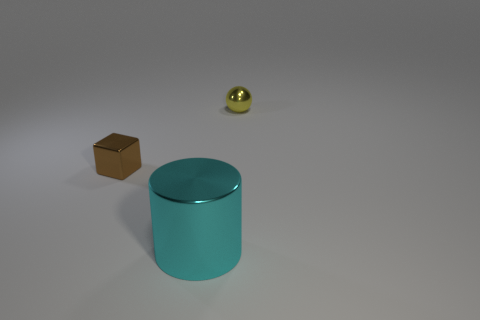The shiny thing behind the tiny object that is to the left of the tiny metallic object that is on the right side of the cyan thing is what color?
Your answer should be compact. Yellow. Is there any other thing that is made of the same material as the cyan thing?
Keep it short and to the point. Yes. There is a small metal object that is left of the yellow shiny ball; is its shape the same as the tiny yellow thing?
Offer a very short reply. No. What is the material of the cyan cylinder?
Your response must be concise. Metal. What is the shape of the metal object that is behind the metallic thing that is on the left side of the cyan object in front of the small brown cube?
Provide a succinct answer. Sphere. What number of other objects are the same shape as the cyan shiny object?
Offer a terse response. 0. Do the big cylinder and the shiny object behind the small block have the same color?
Provide a short and direct response. No. What number of yellow balls are there?
Your answer should be compact. 1. How many objects are tiny yellow balls or metallic cylinders?
Offer a terse response. 2. There is a yellow metal thing; are there any brown metal things left of it?
Give a very brief answer. Yes. 